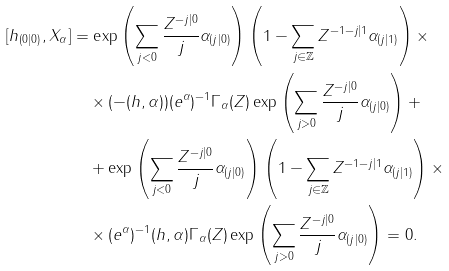Convert formula to latex. <formula><loc_0><loc_0><loc_500><loc_500>{ [ h _ { ( 0 | 0 ) } } , X _ { \alpha } ] & = \exp \left ( \sum _ { j < 0 } \frac { Z ^ { - j | 0 } } { j } \alpha _ { ( j | 0 ) } \right ) \left ( 1 - \sum _ { j \in \mathbb { Z } } Z ^ { - 1 - j | 1 } \alpha _ { ( j | 1 ) } \right ) \times \\ & \quad \times ( - ( h , \alpha ) ) ( e ^ { \alpha } ) ^ { - 1 } \Gamma _ { \alpha } ( Z ) \exp \left ( \sum _ { j > 0 } \frac { Z ^ { - j | 0 } } { j } \alpha _ { ( j | 0 ) } \right ) + \\ & \quad + \exp \left ( \sum _ { j < 0 } \frac { Z ^ { - j | 0 } } { j } \alpha _ { ( j | 0 ) } \right ) \left ( 1 - \sum _ { j \in \mathbb { Z } } Z ^ { - 1 - j | 1 } \alpha _ { ( j | 1 ) } \right ) \times \\ & \quad \times ( e ^ { \alpha } ) ^ { - 1 } ( h , \alpha ) \Gamma _ { \alpha } ( Z ) \exp \left ( \sum _ { j > 0 } \frac { Z ^ { - j | 0 } } { j } \alpha _ { ( j | 0 ) } \right ) = 0 .</formula> 